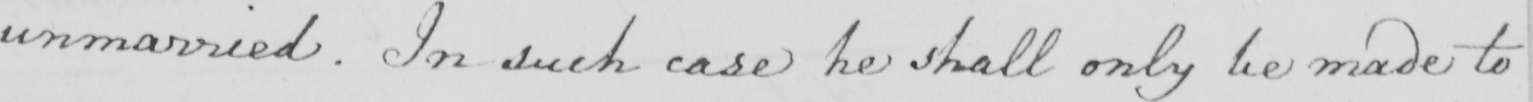What does this handwritten line say? unmarried . In such case he shall only be made to 